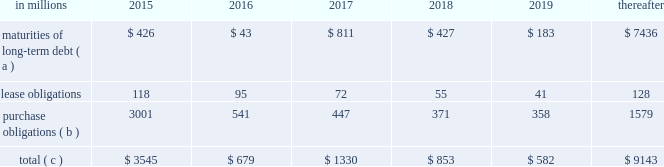The company will continue to rely upon debt and capital markets for the majority of any necessary long-term funding not provided by operating cash flows .
Funding decisions will be guided by our capital structure planning objectives .
The primary goals of the company 2019s capital structure planning are to maximize financial flexibility and preserve liquidity while reducing interest expense .
The majority of international paper 2019s debt is accessed through global public capital markets where we have a wide base of investors .
Maintaining an investment grade credit rating is an important element of international paper 2019s financing strategy .
At december 31 , 2015 , the company held long-term credit ratings of bbb ( stable outlook ) and baa2 ( stable outlook ) by s&p and moody 2019s , respectively .
Contractual obligations for future payments under existing debt and lease commitments and purchase obligations at december 31 , 2015 , were as follows: .
( a ) total debt includes scheduled principal payments only .
( b ) includes $ 2.1 billion relating to fiber supply agreements entered into at the time of the 2006 transformation plan forestland sales and in conjunction with the 2008 acquisition of weyerhaeuser company 2019s containerboard , packaging and recycling business .
( c ) not included in the above table due to the uncertainty as to the amount and timing of the payment are unrecognized tax benefits of approximately $ 101 million .
We consider the undistributed earnings of our foreign subsidiaries as of december 31 , 2015 , to be indefinitely reinvested and , accordingly , no u.s .
Income taxes have been provided thereon .
As of december 31 , 2015 , the amount of cash associated with indefinitely reinvested foreign earnings was approximately $ 600 million .
We do not anticipate the need to repatriate funds to the united states to satisfy domestic liquidity needs arising in the ordinary course of business , including liquidity needs associated with our domestic debt service requirements .
Pension obligations and funding at december 31 , 2015 , the projected benefit obligation for the company 2019s u.s .
Defined benefit plans determined under u.s .
Gaap was approximately $ 3.5 billion higher than the fair value of plan assets .
Approximately $ 3.2 billion of this amount relates to plans that are subject to minimum funding requirements .
Under current irs funding rules , the calculation of minimum funding requirements differs from the calculation of the present value of plan benefits ( the projected benefit obligation ) for accounting purposes .
In december 2008 , the worker , retiree and employer recovery act of 2008 ( wera ) was passed by the u.s .
Congress which provided for pension funding relief and technical corrections .
Funding contributions depend on the funding method selected by the company , and the timing of its implementation , as well as on actual demographic data and the targeted funding level .
The company continually reassesses the amount and timing of any discretionary contributions and elected to make contributions totaling $ 750 million and $ 353 million for the years ended december 31 , 2015 and 2014 , respectively .
At this time , we do not expect to have any required contributions to our plans in 2016 , although the company may elect to make future voluntary contributions .
The timing and amount of future contributions , which could be material , will depend on a number of factors , including the actual earnings and changes in values of plan assets and changes in interest rates .
International paper has announced a voluntary , limited-time opportunity for former employees who are participants in the retirement plan of international paper company ( the pension plan ) to request early payment of their entire pension plan benefit in the form of a single lump sum payment .
Eligible participants who wish to receive the lump sum payment must make an election between february 29 and april 29 , 2016 , and payment is scheduled to be made on or before june 30 , 2016 .
All payments will be made from the pension plan trust assets .
The target population has a total liability of $ 3.0 billion .
The amount of the total payments will depend on the participation rate of eligible participants , but is expected to be approximately $ 1.5 billion .
Based on the expected level of payments , settlement accounting rules will apply in the period in which the payments are made .
This will result in a plan remeasurement and the recognition in earnings of a pro-rata portion of unamortized net actuarial loss .
Ilim holding s.a .
Shareholder 2019s agreement in october 2007 , in connection with the formation of the ilim holding s.a .
Joint venture , international paper entered into a shareholder 2019s agreement that includes provisions relating to the reconciliation of disputes among the partners .
This agreement was amended on may 7 , 2014 .
Pursuant to the amended agreement , beginning on january 1 , 2017 , either the company or its partners may commence certain procedures specified under the deadlock provisions .
If these or any other deadlock provisions are commenced , the company may in certain situations , choose to purchase its partners 2019 50% ( 50 % ) interest in ilim .
Any such transaction would be subject to review and approval by russian and other relevant antitrust authorities .
Any such purchase by international paper would result in the consolidation of ilim 2019s financial position and results of operations in all subsequent periods. .
What was the ratio of discretionary company contributions in 2015 compared to 2014? 
Computations: (750 / 353)
Answer: 2.12465. 